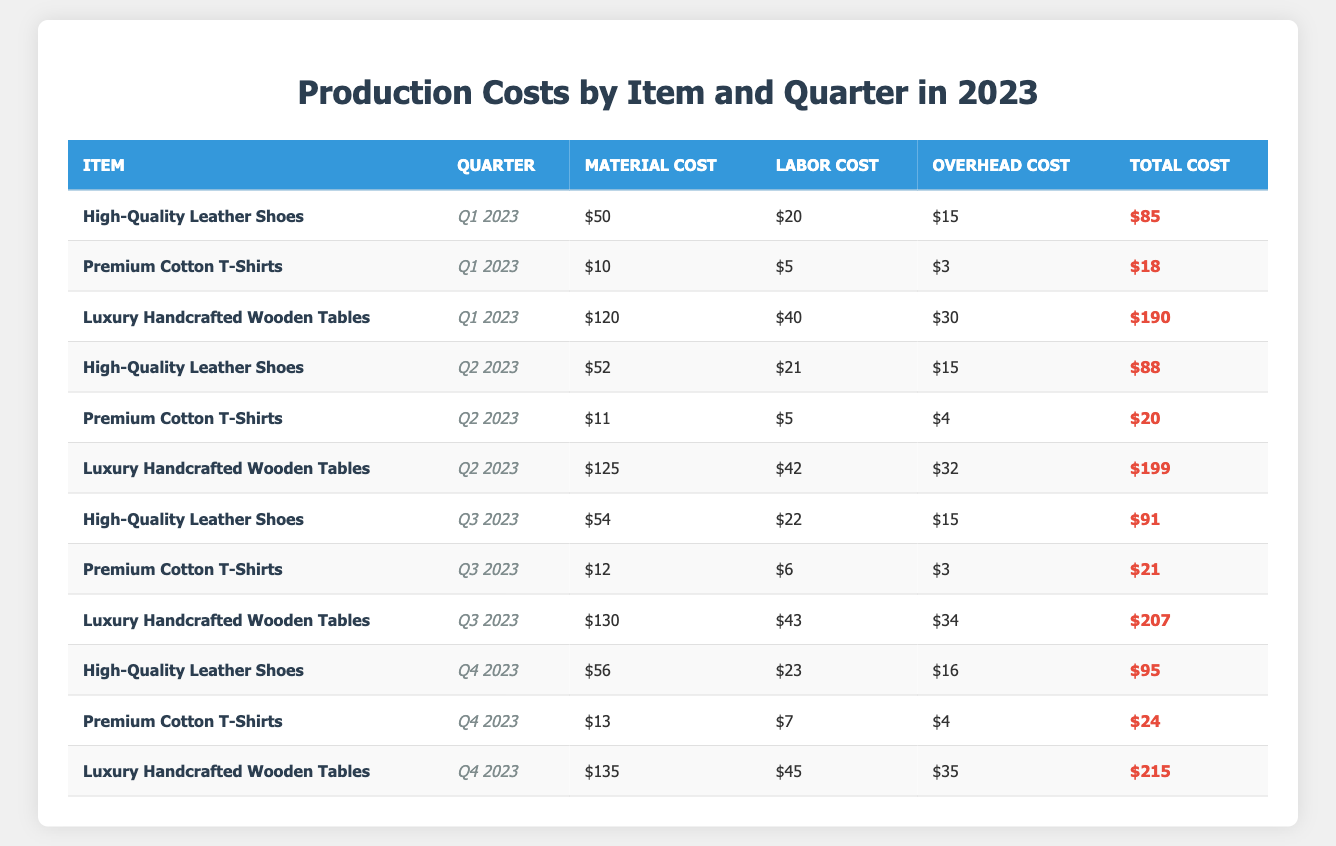What is the total cost of Premium Cotton T-Shirts in Q2 2023? The total cost for Premium Cotton T-Shirts in Q2 2023 is listed in the table as $20.
Answer: $20 What is the material cost for Luxury Handcrafted Wooden Tables in Q3 2023? The material cost for Luxury Handcrafted Wooden Tables in Q3 2023 is $130, as shown in the table.
Answer: $130 Which item had the highest total cost in Q4 2023? The table shows that Luxury Handcrafted Wooden Tables had the highest total cost in Q4 2023 at $215.
Answer: Luxury Handcrafted Wooden Tables What is the average total cost of High-Quality Leather Shoes across all quarters in 2023? The total costs for High-Quality Leather Shoes are $85 (Q1), $88 (Q2), $91 (Q3), and $95 (Q4). Summing these gives $359. Dividing by 4 (the number of quarters) gives an average of $89.75.
Answer: $89.75 Is the total cost of Premium Cotton T-Shirts in Q3 2023 greater than in Q1 2023? The total cost for Premium Cotton T-Shirts in Q3 2023 is $21, while in Q1 2023 it is $18. Since $21 is greater than $18, the statement is true.
Answer: Yes What is the difference in total cost between Luxury Handcrafted Wooden Tables in Q2 2023 and Q4 2023? The total cost for Luxury Handcrafted Wooden Tables in Q2 2023 is $199, and in Q4 2023, it is $215. Subtracting gives $215 - $199 = $16.
Answer: $16 Which quarter had the lowest total cost for Premium Cotton T-Shirts? Looking at the table, the total costs for Premium Cotton T-Shirts are $18 (Q1), $20 (Q2), $21 (Q3), and $24 (Q4). The lowest total cost is $18 in Q1 2023.
Answer: Q1 2023 Calculate the total material cost for High-Quality Leather Shoes for all quarters. The material costs are $50 (Q1), $52 (Q2), $54 (Q3), and $56 (Q4). Summing these gives $50 + $52 + $54 + $56 = $212.
Answer: $212 What was the overhead cost for Premium Cotton T-Shirts in Q4 2023? The overhead cost for Premium Cotton T-Shirts in Q4 2023 is noted in the table as $4.
Answer: $4 Did the labor costs for Luxury Handcrafted Wooden Tables increase every quarter in 2023? The labor costs are $40 (Q1), $42 (Q2), $43 (Q3), and $45 (Q4). Since all values are increasing, the answer is yes.
Answer: Yes 